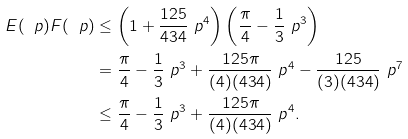<formula> <loc_0><loc_0><loc_500><loc_500>E ( \ p ) F ( \ p ) & \leq \left ( 1 + \frac { 1 2 5 } { 4 3 4 } \ p ^ { 4 } \right ) \left ( \frac { \pi } { 4 } - \frac { 1 } { 3 } \ p ^ { 3 } \right ) \\ & = \frac { \pi } { 4 } - \frac { 1 } { 3 } \ p ^ { 3 } + \frac { 1 2 5 \pi } { ( 4 ) ( 4 3 4 ) } \ p ^ { 4 } - \frac { 1 2 5 } { ( 3 ) ( 4 3 4 ) } \ p ^ { 7 } \\ & \leq \frac { \pi } { 4 } - \frac { 1 } { 3 } \ p ^ { 3 } + \frac { 1 2 5 \pi } { ( 4 ) ( 4 3 4 ) } \ p ^ { 4 } .</formula> 